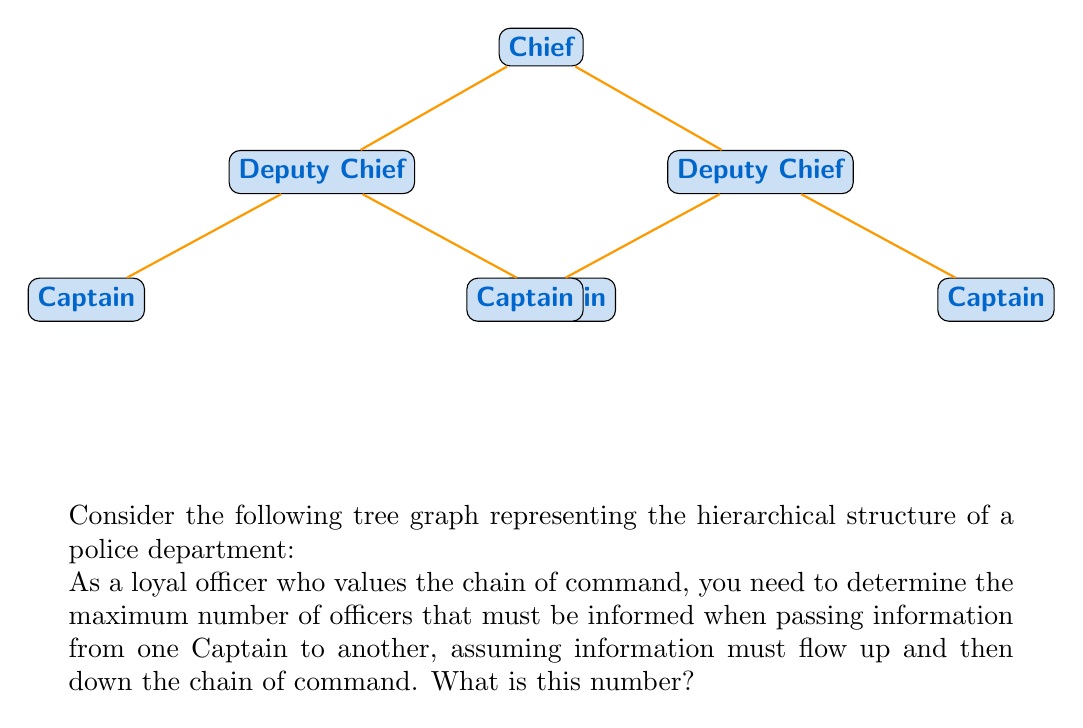Provide a solution to this math problem. Let's approach this step-by-step:

1) First, we need to understand the structure of the tree:
   - The Chief is at the top (root)
   - There are two Deputy Chiefs below the Chief
   - Each Deputy Chief has two Captains under them

2) To pass information from one Captain to another, the message must go up the chain of command until it reaches a common superior, then down to the target Captain.

3) The worst-case scenario (maximum number of officers informed) would be when passing information between Captains under different Deputy Chiefs.

4) Let's count the officers involved in this worst-case scenario:
   - Starting Captain (1 officer)
   - Up to their Deputy Chief (2 officers)
   - Up to the Chief (3 officers)
   - Down to the other Deputy Chief (4 officers)
   - Down to the target Captain (5 officers)

5) Therefore, in the worst case, 5 officers must be informed.

6) We can verify this mathematically using the concept of tree depth:
   - Let $d$ be the depth of the tree (number of edges in the longest path from root to leaf)
   - In this case, $d = 2$
   - The formula for maximum officers informed is $2d + 1 = 2(2) + 1 = 5$

This approach ensures strict adherence to the chain of command, which aligns with the given persona of a loyal officer who values hierarchical structure.
Answer: 5 officers 